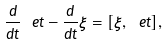<formula> <loc_0><loc_0><loc_500><loc_500>\frac { d } { d t } \ e t - \frac { d } { d t } \xi = [ \xi , \ e t ] ,</formula> 